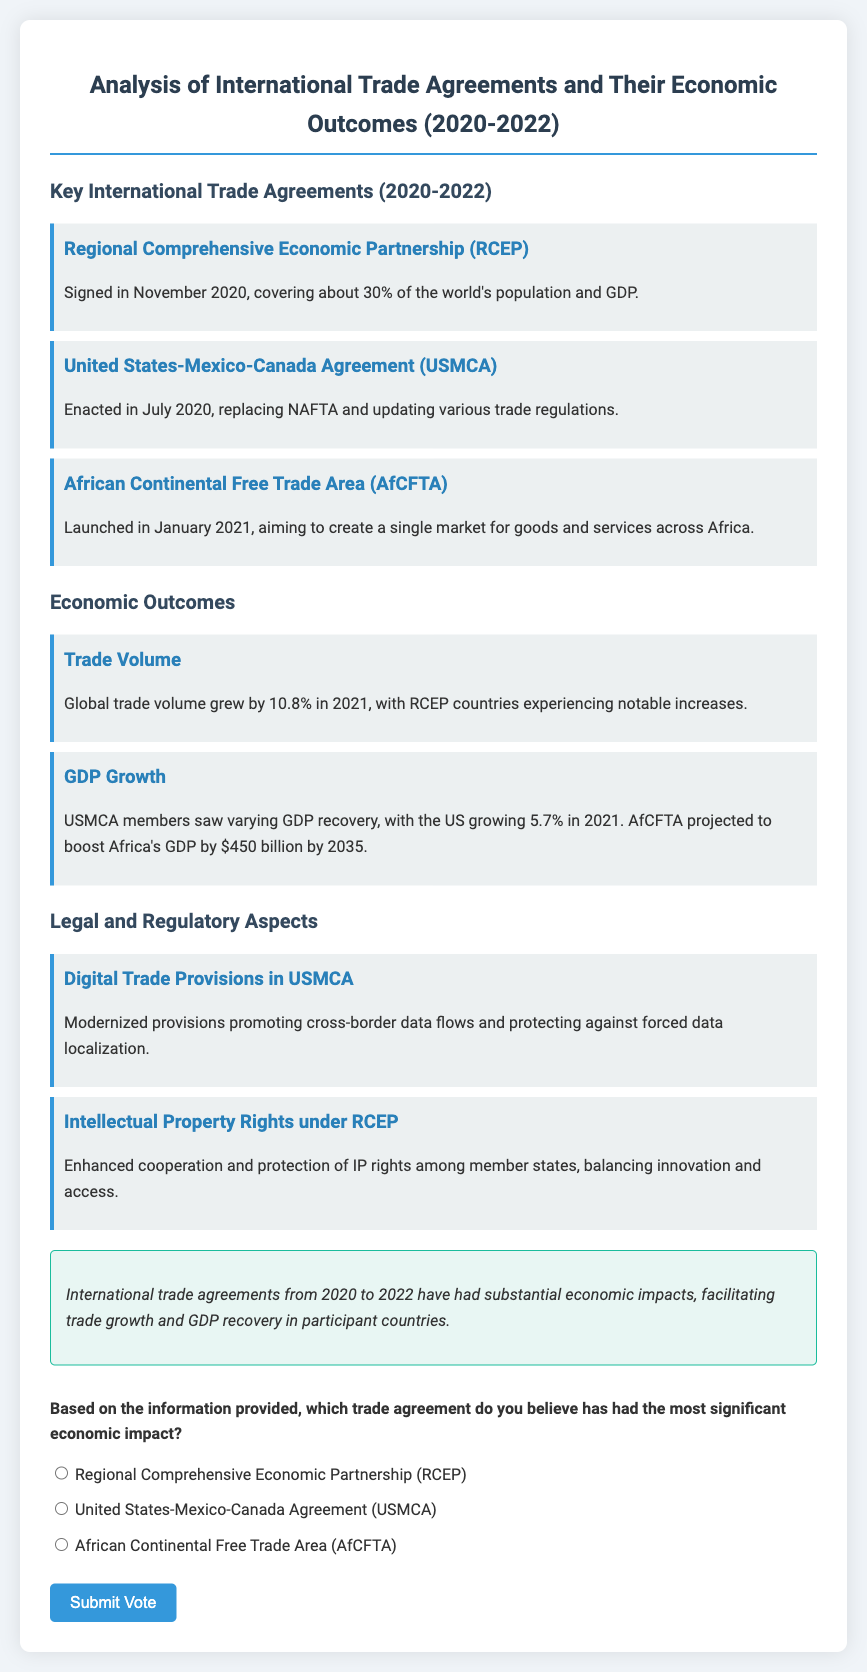What is the Regional Comprehensive Economic Partnership? The Regional Comprehensive Economic Partnership is a trade agreement signed in November 2020, covering about 30% of the world's population and GDP.
Answer: A trade agreement When was the United States-Mexico-Canada Agreement enacted? The United States-Mexico-Canada Agreement was enacted in July 2020.
Answer: July 2020 What percentage did global trade volume grow by in 2021? Global trade volume grew by 10.8% in 2021.
Answer: 10.8% What GDP growth did the US experience in 2021? The US grew by 5.7% in 2021.
Answer: 5.7% What is projected to boost Africa's GDP by $450 billion by 2035? The African Continental Free Trade Area is projected to boost Africa's GDP by $450 billion by 2035.
Answer: African Continental Free Trade Area What type of provisions does the USMCA modernize? The USMCA modernizes digital trade provisions promoting cross-border data flows.
Answer: Digital trade provisions Which trade agreement enhanced cooperation on Intellectual Property Rights? The RCEP enhanced cooperation and protection of IP rights among member states.
Answer: RCEP Which economic outcome is associated with RCEP countries? Notable increases in trade volume are associated with RCEP countries.
Answer: Trade volume In which section is the conclusion found? The conclusion is found in the section titled 'conclusion'.
Answer: conclusion 